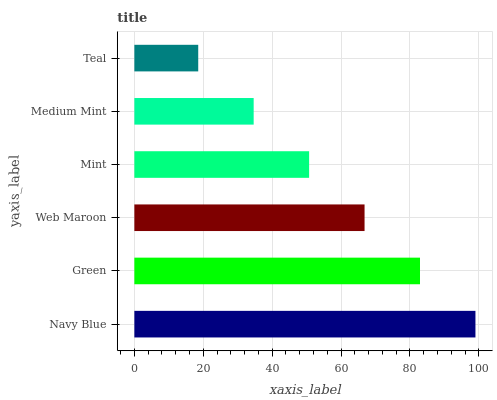Is Teal the minimum?
Answer yes or no. Yes. Is Navy Blue the maximum?
Answer yes or no. Yes. Is Green the minimum?
Answer yes or no. No. Is Green the maximum?
Answer yes or no. No. Is Navy Blue greater than Green?
Answer yes or no. Yes. Is Green less than Navy Blue?
Answer yes or no. Yes. Is Green greater than Navy Blue?
Answer yes or no. No. Is Navy Blue less than Green?
Answer yes or no. No. Is Web Maroon the high median?
Answer yes or no. Yes. Is Mint the low median?
Answer yes or no. Yes. Is Navy Blue the high median?
Answer yes or no. No. Is Navy Blue the low median?
Answer yes or no. No. 